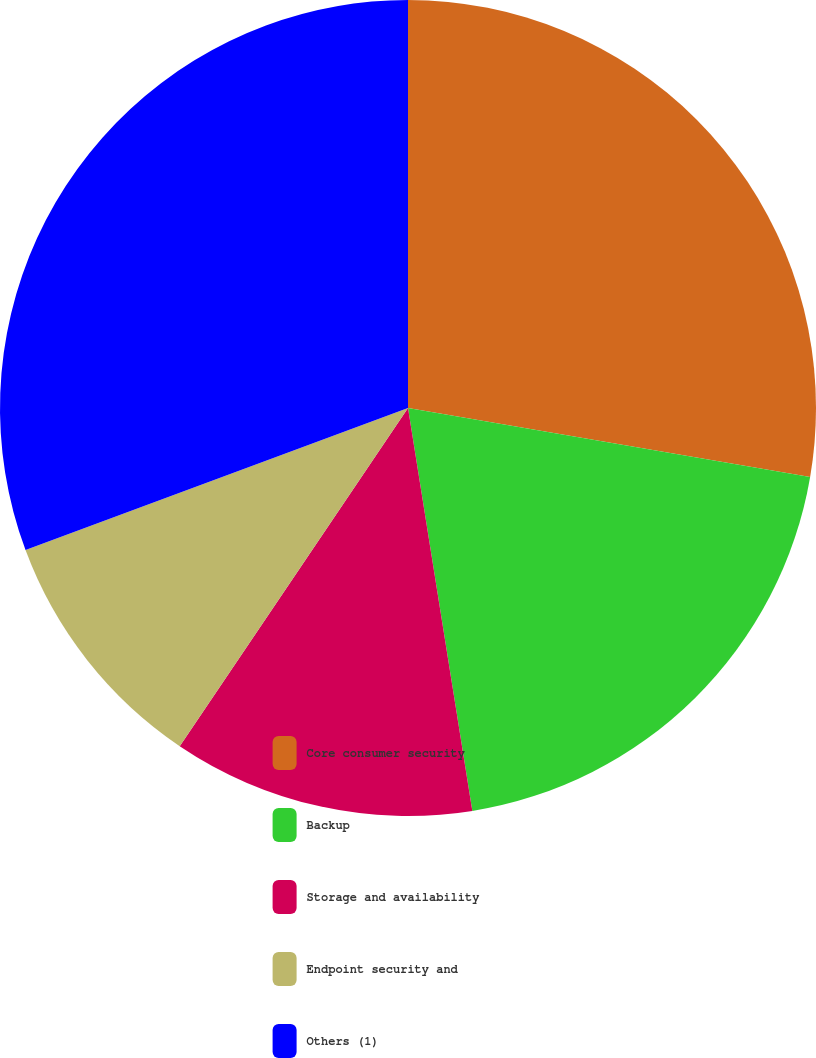<chart> <loc_0><loc_0><loc_500><loc_500><pie_chart><fcel>Core consumer security<fcel>Backup<fcel>Storage and availability<fcel>Endpoint security and<fcel>Others (1)<nl><fcel>27.7%<fcel>19.78%<fcel>11.97%<fcel>9.89%<fcel>30.66%<nl></chart> 